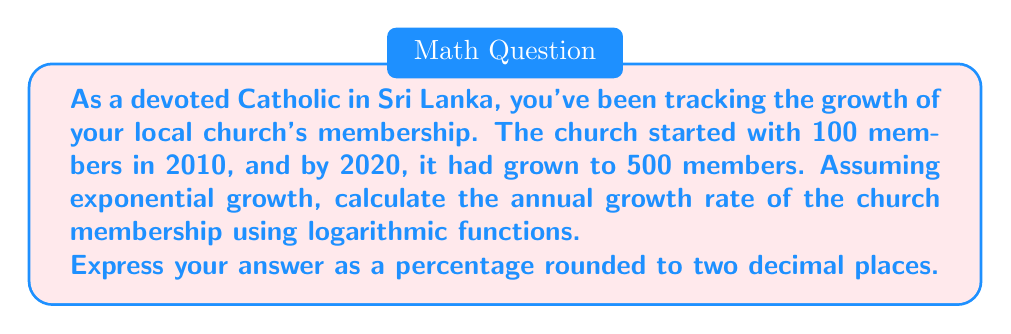Can you answer this question? Let's approach this step-by-step using logarithmic functions:

1) The exponential growth formula is:
   $$A = P(1 + r)^t$$
   where:
   $A$ is the final amount
   $P$ is the initial amount
   $r$ is the annual growth rate (in decimal form)
   $t$ is the time in years

2) We know:
   $P = 100$ (initial members in 2010)
   $A = 500$ (final members in 2020)
   $t = 10$ years

3) Substituting these values:
   $$500 = 100(1 + r)^{10}$$

4) Divide both sides by 100:
   $$5 = (1 + r)^{10}$$

5) Take the natural logarithm of both sides:
   $$\ln(5) = \ln((1 + r)^{10})$$

6) Use the logarithm property $\ln(x^n) = n\ln(x)$:
   $$\ln(5) = 10\ln(1 + r)$$

7) Divide both sides by 10:
   $$\frac{\ln(5)}{10} = \ln(1 + r)$$

8) Take $e$ to the power of both sides:
   $$e^{\frac{\ln(5)}{10}} = e^{\ln(1 + r)} = 1 + r$$

9) Subtract 1 from both sides:
   $$e^{\frac{\ln(5)}{10}} - 1 = r$$

10) Calculate:
    $$r = e^{\frac{\ln(5)}{10}} - 1 \approx 0.1746$$

11) Convert to percentage:
    $$0.1746 \times 100\% = 17.46\%$$

Rounded to two decimal places, this is 17.46%.
Answer: 17.46% 